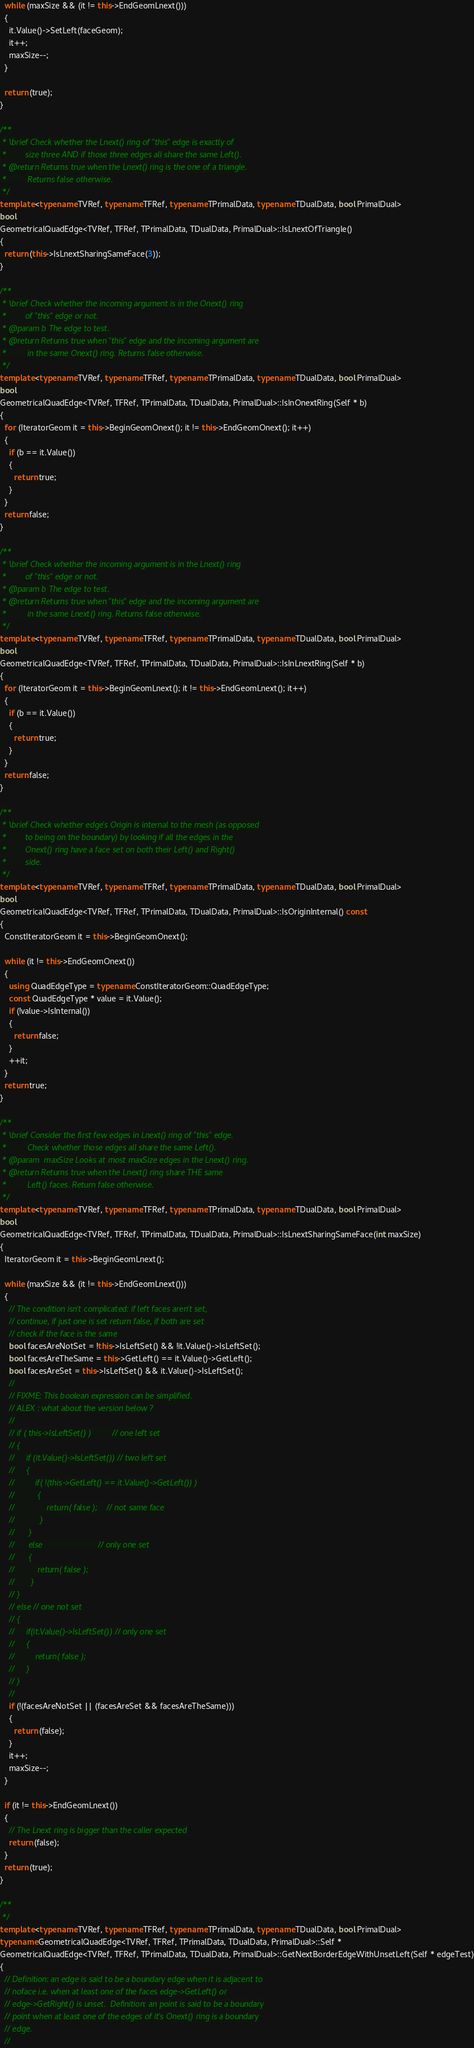Convert code to text. <code><loc_0><loc_0><loc_500><loc_500><_C++_>  while (maxSize && (it != this->EndGeomLnext()))
  {
    it.Value()->SetLeft(faceGeom);
    it++;
    maxSize--;
  }

  return (true);
}

/**
 * \brief Check whether the Lnext() ring of "this" edge is exactly of
 *        size three AND if those three edges all share the same Left().
 * @return Returns true when the Lnext() ring is the one of a triangle.
 *         Returns false otherwise.
 */
template <typename TVRef, typename TFRef, typename TPrimalData, typename TDualData, bool PrimalDual>
bool
GeometricalQuadEdge<TVRef, TFRef, TPrimalData, TDualData, PrimalDual>::IsLnextOfTriangle()
{
  return (this->IsLnextSharingSameFace(3));
}

/**
 * \brief Check whether the incoming argument is in the Onext() ring
 *        of "this" edge or not.
 * @param b The edge to test.
 * @return Returns true when "this" edge and the incoming argument are
 *         in the same Onext() ring. Returns false otherwise.
 */
template <typename TVRef, typename TFRef, typename TPrimalData, typename TDualData, bool PrimalDual>
bool
GeometricalQuadEdge<TVRef, TFRef, TPrimalData, TDualData, PrimalDual>::IsInOnextRing(Self * b)
{
  for (IteratorGeom it = this->BeginGeomOnext(); it != this->EndGeomOnext(); it++)
  {
    if (b == it.Value())
    {
      return true;
    }
  }
  return false;
}

/**
 * \brief Check whether the incoming argument is in the Lnext() ring
 *        of "this" edge or not.
 * @param b The edge to test.
 * @return Returns true when "this" edge and the incoming argument are
 *         in the same Lnext() ring. Returns false otherwise.
 */
template <typename TVRef, typename TFRef, typename TPrimalData, typename TDualData, bool PrimalDual>
bool
GeometricalQuadEdge<TVRef, TFRef, TPrimalData, TDualData, PrimalDual>::IsInLnextRing(Self * b)
{
  for (IteratorGeom it = this->BeginGeomLnext(); it != this->EndGeomLnext(); it++)
  {
    if (b == it.Value())
    {
      return true;
    }
  }
  return false;
}

/**
 * \brief Check whether edge's Origin is internal to the mesh (as opposed
 *        to being on the boundary) by looking if all the edges in the
 *        Onext() ring have a face set on both their Left() and Right()
 *        side.
 */
template <typename TVRef, typename TFRef, typename TPrimalData, typename TDualData, bool PrimalDual>
bool
GeometricalQuadEdge<TVRef, TFRef, TPrimalData, TDualData, PrimalDual>::IsOriginInternal() const
{
  ConstIteratorGeom it = this->BeginGeomOnext();

  while (it != this->EndGeomOnext())
  {
    using QuadEdgeType = typename ConstIteratorGeom::QuadEdgeType;
    const QuadEdgeType * value = it.Value();
    if (!value->IsInternal())
    {
      return false;
    }
    ++it;
  }
  return true;
}

/**
 * \brief Consider the first few edges in Lnext() ring of "this" edge.
 *         Check whether those edges all share the same Left().
 * @param  maxSize Looks at most maxSize edges in the Lnext() ring.
 * @return Returns true when the Lnext() ring share THE same
 *         Left() faces. Return false otherwise.
 */
template <typename TVRef, typename TFRef, typename TPrimalData, typename TDualData, bool PrimalDual>
bool
GeometricalQuadEdge<TVRef, TFRef, TPrimalData, TDualData, PrimalDual>::IsLnextSharingSameFace(int maxSize)
{
  IteratorGeom it = this->BeginGeomLnext();

  while (maxSize && (it != this->EndGeomLnext()))
  {
    // The condition isn't complicated: if left faces aren't set,
    // continue, if just one is set return false, if both are set
    // check if the face is the same
    bool facesAreNotSet = !this->IsLeftSet() && !it.Value()->IsLeftSet();
    bool facesAreTheSame = this->GetLeft() == it.Value()->GetLeft();
    bool facesAreSet = this->IsLeftSet() && it.Value()->IsLeftSet();
    //
    // FIXME: This boolean expression can be simplified.
    // ALEX : what about the version below ?
    //
    // if ( this->IsLeftSet() )         // one left set
    // {
    //     if (it.Value()->IsLeftSet()) // two left set
    //     {
    //         if( !(this->GetLeft() == it.Value()->GetLeft()) )
    //          {
    //              return( false );    // not same face
    //           }
    //      }
    //      else                        // only one set
    //      {
    //          return( false );
    //       }
    // }
    // else // one not set
    // {
    //     if(it.Value()->IsLeftSet()) // only one set
    //     {
    //         return( false );
    //     }
    // }
    //
    if (!(facesAreNotSet || (facesAreSet && facesAreTheSame)))
    {
      return (false);
    }
    it++;
    maxSize--;
  }

  if (it != this->EndGeomLnext())
  {
    // The Lnext ring is bigger than the caller expected
    return (false);
  }
  return (true);
}

/**
 */
template <typename TVRef, typename TFRef, typename TPrimalData, typename TDualData, bool PrimalDual>
typename GeometricalQuadEdge<TVRef, TFRef, TPrimalData, TDualData, PrimalDual>::Self *
GeometricalQuadEdge<TVRef, TFRef, TPrimalData, TDualData, PrimalDual>::GetNextBorderEdgeWithUnsetLeft(Self * edgeTest)
{
  // Definition: an edge is said to be a boundary edge when it is adjacent to
  // noface i.e. when at least one of the faces edge->GetLeft() or
  // edge->GetRight() is unset.  Definition: an point is said to be a boundary
  // point when at least one of the edges of it's Onext() ring is a boundary
  // edge.
  //</code> 